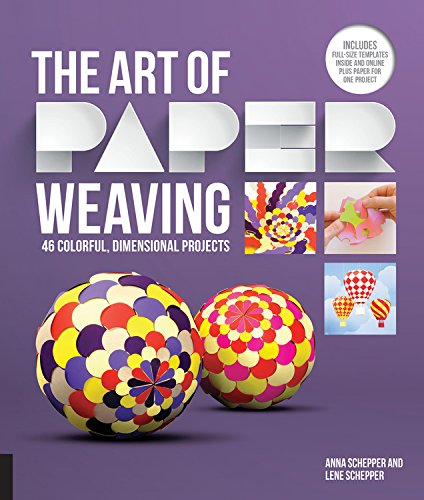Who is the author of this book?
Answer the question using a single word or phrase. Anna Schepper What is the title of this book? The Art of Paper Weaving: 46 Colorful, Dimensional Projects--Includes Full-Size Templates Inside & Online Plus Practice Paper for One Project What type of book is this? Crafts, Hobbies & Home Is this book related to Crafts, Hobbies & Home? Yes Is this book related to Calendars? No 